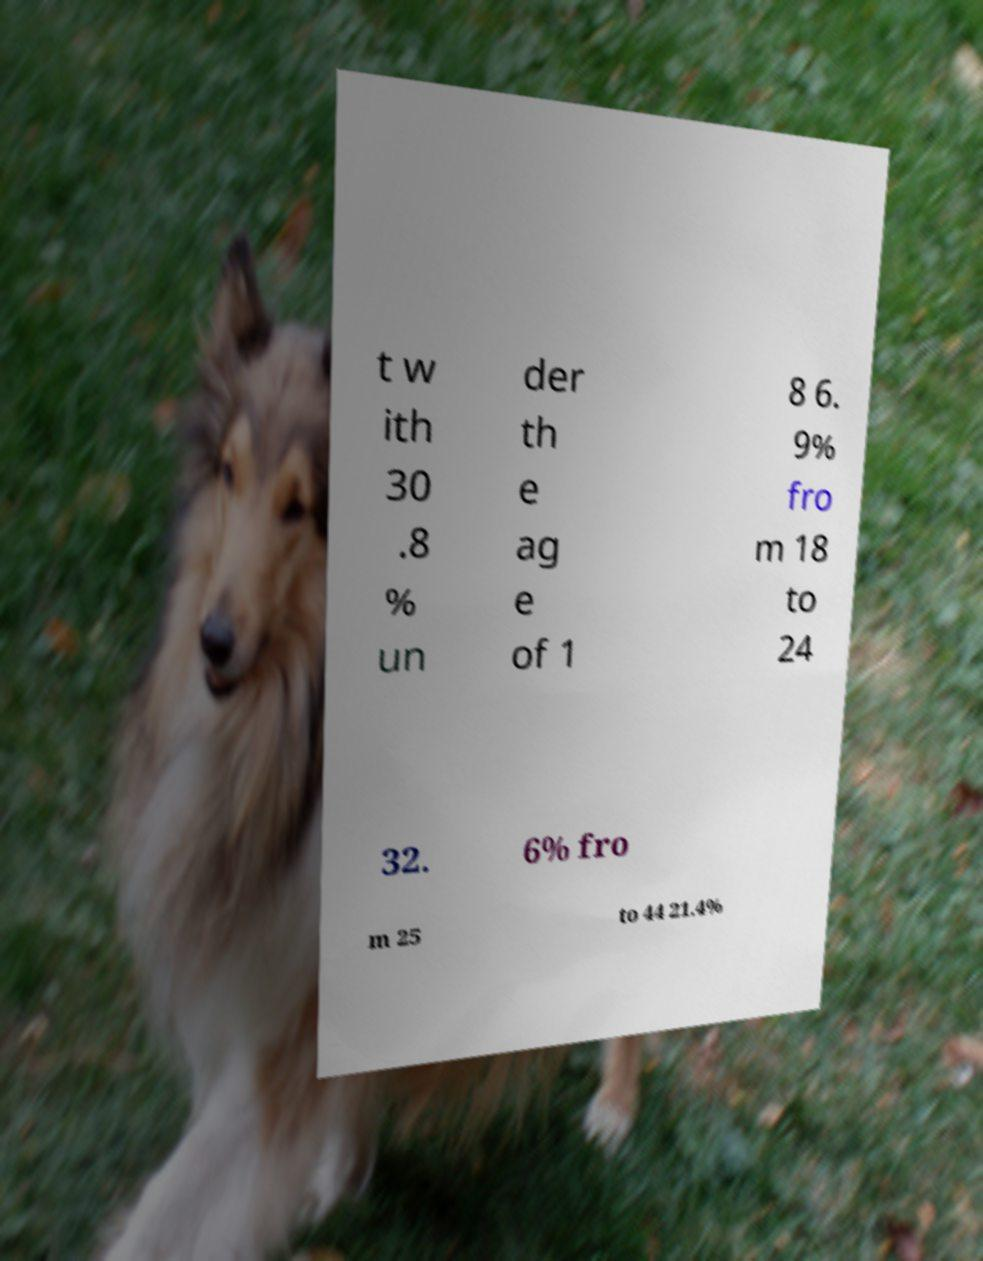Can you read and provide the text displayed in the image?This photo seems to have some interesting text. Can you extract and type it out for me? t w ith 30 .8 % un der th e ag e of 1 8 6. 9% fro m 18 to 24 32. 6% fro m 25 to 44 21.4% 